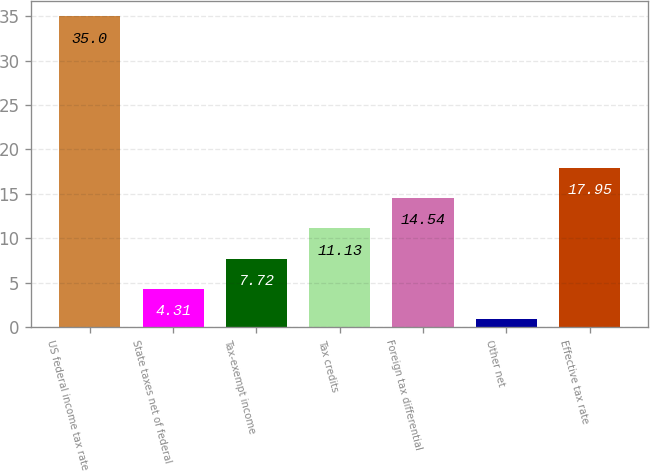Convert chart. <chart><loc_0><loc_0><loc_500><loc_500><bar_chart><fcel>US federal income tax rate<fcel>State taxes net of federal<fcel>Tax-exempt income<fcel>Tax credits<fcel>Foreign tax differential<fcel>Other net<fcel>Effective tax rate<nl><fcel>35<fcel>4.31<fcel>7.72<fcel>11.13<fcel>14.54<fcel>0.9<fcel>17.95<nl></chart> 